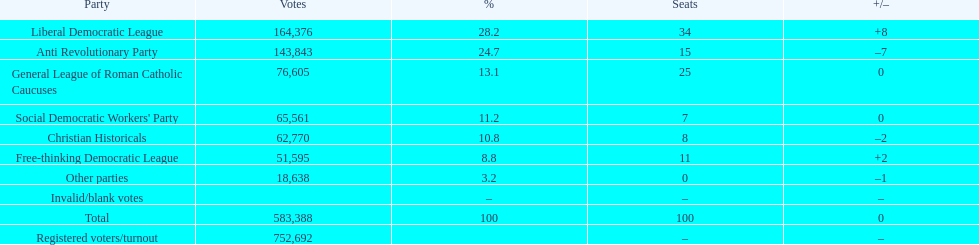What was the vote margin between the liberal democratic league and the free-thinking democratic league? 112,781. 